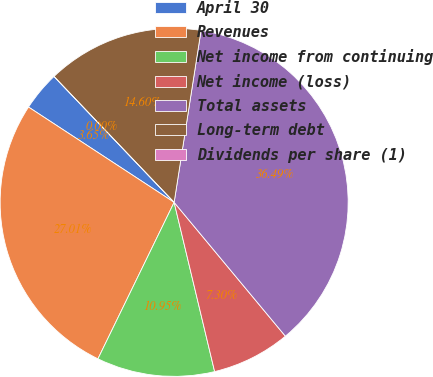<chart> <loc_0><loc_0><loc_500><loc_500><pie_chart><fcel>April 30<fcel>Revenues<fcel>Net income from continuing<fcel>Net income (loss)<fcel>Total assets<fcel>Long-term debt<fcel>Dividends per share (1)<nl><fcel>3.65%<fcel>27.01%<fcel>10.95%<fcel>7.3%<fcel>36.49%<fcel>14.6%<fcel>0.0%<nl></chart> 